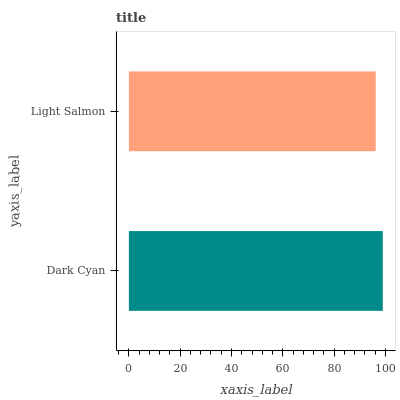Is Light Salmon the minimum?
Answer yes or no. Yes. Is Dark Cyan the maximum?
Answer yes or no. Yes. Is Light Salmon the maximum?
Answer yes or no. No. Is Dark Cyan greater than Light Salmon?
Answer yes or no. Yes. Is Light Salmon less than Dark Cyan?
Answer yes or no. Yes. Is Light Salmon greater than Dark Cyan?
Answer yes or no. No. Is Dark Cyan less than Light Salmon?
Answer yes or no. No. Is Dark Cyan the high median?
Answer yes or no. Yes. Is Light Salmon the low median?
Answer yes or no. Yes. Is Light Salmon the high median?
Answer yes or no. No. Is Dark Cyan the low median?
Answer yes or no. No. 